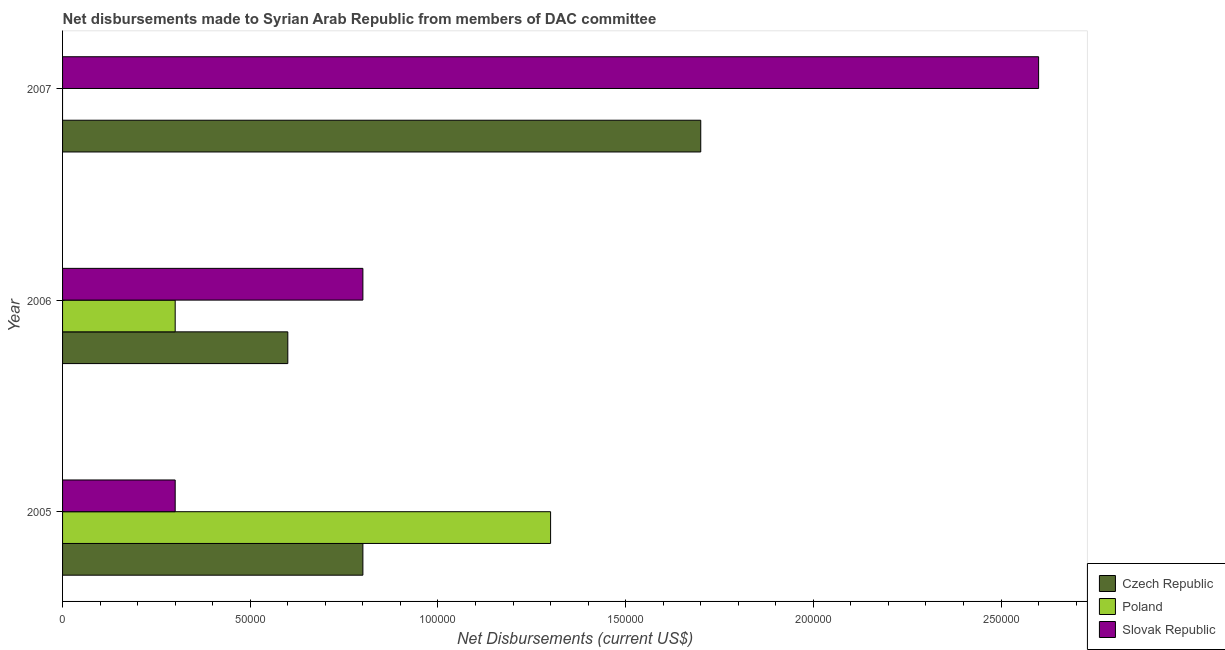How many groups of bars are there?
Your answer should be compact. 3. Are the number of bars per tick equal to the number of legend labels?
Offer a terse response. No. Are the number of bars on each tick of the Y-axis equal?
Offer a very short reply. No. How many bars are there on the 2nd tick from the top?
Provide a short and direct response. 3. What is the label of the 3rd group of bars from the top?
Your answer should be very brief. 2005. What is the net disbursements made by slovak republic in 2007?
Your answer should be very brief. 2.60e+05. Across all years, what is the maximum net disbursements made by czech republic?
Offer a very short reply. 1.70e+05. Across all years, what is the minimum net disbursements made by czech republic?
Make the answer very short. 6.00e+04. In which year was the net disbursements made by czech republic maximum?
Provide a succinct answer. 2007. What is the total net disbursements made by poland in the graph?
Keep it short and to the point. 1.60e+05. What is the difference between the net disbursements made by slovak republic in 2005 and that in 2007?
Offer a terse response. -2.30e+05. What is the difference between the net disbursements made by czech republic in 2007 and the net disbursements made by poland in 2005?
Make the answer very short. 4.00e+04. What is the average net disbursements made by poland per year?
Your answer should be very brief. 5.33e+04. In the year 2006, what is the difference between the net disbursements made by slovak republic and net disbursements made by czech republic?
Your response must be concise. 2.00e+04. In how many years, is the net disbursements made by slovak republic greater than 20000 US$?
Keep it short and to the point. 3. What is the ratio of the net disbursements made by czech republic in 2005 to that in 2006?
Keep it short and to the point. 1.33. What is the difference between the highest and the second highest net disbursements made by slovak republic?
Keep it short and to the point. 1.80e+05. What is the difference between the highest and the lowest net disbursements made by czech republic?
Ensure brevity in your answer.  1.10e+05. Are all the bars in the graph horizontal?
Give a very brief answer. Yes. What is the difference between two consecutive major ticks on the X-axis?
Provide a succinct answer. 5.00e+04. How are the legend labels stacked?
Offer a terse response. Vertical. What is the title of the graph?
Offer a very short reply. Net disbursements made to Syrian Arab Republic from members of DAC committee. What is the label or title of the X-axis?
Your response must be concise. Net Disbursements (current US$). What is the Net Disbursements (current US$) in Poland in 2007?
Give a very brief answer. 0. What is the Net Disbursements (current US$) of Slovak Republic in 2007?
Provide a succinct answer. 2.60e+05. Across all years, what is the maximum Net Disbursements (current US$) in Czech Republic?
Your response must be concise. 1.70e+05. Across all years, what is the maximum Net Disbursements (current US$) of Poland?
Offer a very short reply. 1.30e+05. Across all years, what is the minimum Net Disbursements (current US$) of Czech Republic?
Offer a very short reply. 6.00e+04. What is the total Net Disbursements (current US$) in Czech Republic in the graph?
Provide a short and direct response. 3.10e+05. What is the total Net Disbursements (current US$) in Slovak Republic in the graph?
Your answer should be compact. 3.70e+05. What is the difference between the Net Disbursements (current US$) in Czech Republic in 2005 and that in 2006?
Your answer should be very brief. 2.00e+04. What is the difference between the Net Disbursements (current US$) in Poland in 2005 and that in 2006?
Make the answer very short. 1.00e+05. What is the difference between the Net Disbursements (current US$) of Slovak Republic in 2005 and that in 2006?
Keep it short and to the point. -5.00e+04. What is the difference between the Net Disbursements (current US$) in Czech Republic in 2006 and that in 2007?
Ensure brevity in your answer.  -1.10e+05. What is the difference between the Net Disbursements (current US$) of Poland in 2005 and the Net Disbursements (current US$) of Slovak Republic in 2006?
Give a very brief answer. 5.00e+04. What is the difference between the Net Disbursements (current US$) in Czech Republic in 2005 and the Net Disbursements (current US$) in Slovak Republic in 2007?
Make the answer very short. -1.80e+05. What is the average Net Disbursements (current US$) in Czech Republic per year?
Make the answer very short. 1.03e+05. What is the average Net Disbursements (current US$) of Poland per year?
Provide a succinct answer. 5.33e+04. What is the average Net Disbursements (current US$) of Slovak Republic per year?
Make the answer very short. 1.23e+05. In the year 2005, what is the difference between the Net Disbursements (current US$) of Czech Republic and Net Disbursements (current US$) of Poland?
Provide a succinct answer. -5.00e+04. In the year 2005, what is the difference between the Net Disbursements (current US$) of Czech Republic and Net Disbursements (current US$) of Slovak Republic?
Keep it short and to the point. 5.00e+04. In the year 2005, what is the difference between the Net Disbursements (current US$) of Poland and Net Disbursements (current US$) of Slovak Republic?
Ensure brevity in your answer.  1.00e+05. In the year 2006, what is the difference between the Net Disbursements (current US$) in Czech Republic and Net Disbursements (current US$) in Poland?
Provide a short and direct response. 3.00e+04. In the year 2006, what is the difference between the Net Disbursements (current US$) of Czech Republic and Net Disbursements (current US$) of Slovak Republic?
Your response must be concise. -2.00e+04. In the year 2007, what is the difference between the Net Disbursements (current US$) of Czech Republic and Net Disbursements (current US$) of Slovak Republic?
Your response must be concise. -9.00e+04. What is the ratio of the Net Disbursements (current US$) in Czech Republic in 2005 to that in 2006?
Offer a terse response. 1.33. What is the ratio of the Net Disbursements (current US$) in Poland in 2005 to that in 2006?
Your answer should be very brief. 4.33. What is the ratio of the Net Disbursements (current US$) in Slovak Republic in 2005 to that in 2006?
Give a very brief answer. 0.38. What is the ratio of the Net Disbursements (current US$) in Czech Republic in 2005 to that in 2007?
Offer a very short reply. 0.47. What is the ratio of the Net Disbursements (current US$) of Slovak Republic in 2005 to that in 2007?
Make the answer very short. 0.12. What is the ratio of the Net Disbursements (current US$) of Czech Republic in 2006 to that in 2007?
Offer a very short reply. 0.35. What is the ratio of the Net Disbursements (current US$) of Slovak Republic in 2006 to that in 2007?
Give a very brief answer. 0.31. What is the difference between the highest and the second highest Net Disbursements (current US$) of Slovak Republic?
Offer a very short reply. 1.80e+05. 